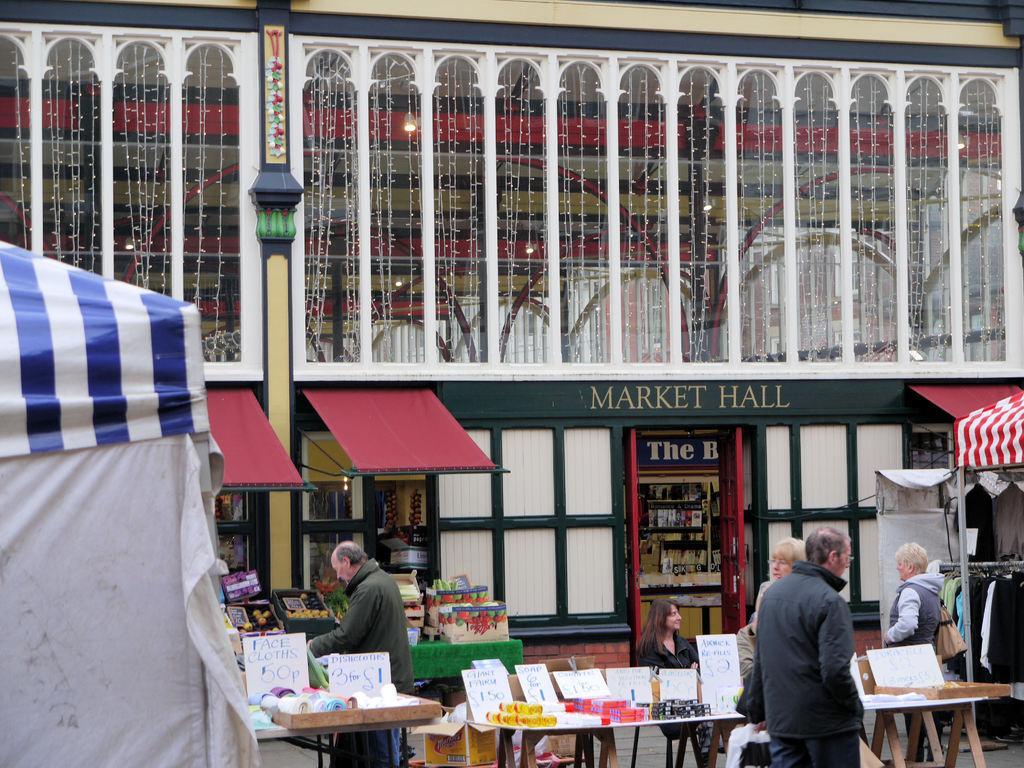In one or two sentences, can you explain what this image depicts? In this image we see people standing and there are tables in front of them and behind them there is market hall 